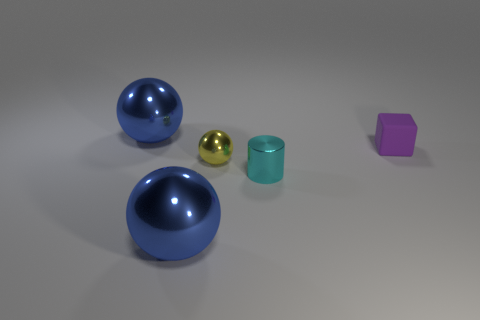Subtract all blue spheres. How many were subtracted if there are1blue spheres left? 1 Subtract all blue balls. How many balls are left? 1 Add 1 large blue cubes. How many objects exist? 6 Subtract all balls. How many objects are left? 2 Subtract all yellow spheres. How many spheres are left? 2 Subtract all blue balls. How many red blocks are left? 0 Subtract all small cubes. Subtract all yellow objects. How many objects are left? 3 Add 4 large blue shiny objects. How many large blue shiny objects are left? 6 Add 4 tiny yellow shiny objects. How many tiny yellow shiny objects exist? 5 Subtract 0 green cylinders. How many objects are left? 5 